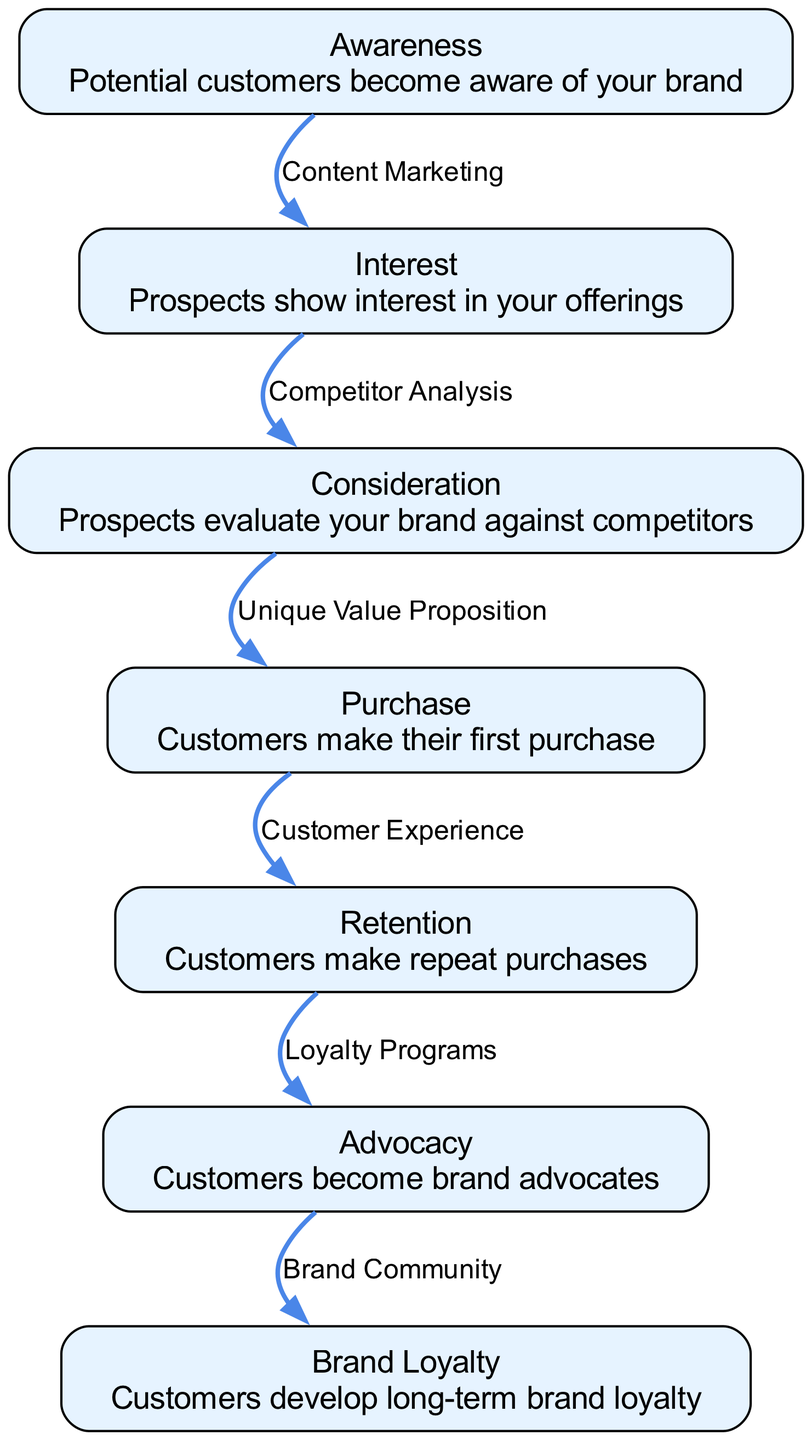What is the first stage in the marketing funnel? The first stage in the marketing funnel is "Awareness," where potential customers become aware of the brand.
Answer: Awareness How many nodes are present in the diagram? Counting the nodes listed in the diagram, there are seven distinct stages or nodes: Awareness, Interest, Consideration, Purchase, Retention, Advocacy, and Brand Loyalty.
Answer: 7 What is the relationship between Interest and Consideration? The diagram shows a directed edge from Interest to Consideration, labeled "Competitor Analysis," indicating that prospects evaluate brands against competitors after showing interest.
Answer: Competitor Analysis Which stage comes after Purchase? The stage that follows Purchase in the conversion process is Retention, where customers make repeat purchases after their initial purchase.
Answer: Retention What is the final stage of the marketing funnel? The last stage in the marketing funnel is "Brand Loyalty," where customers develop long-term loyalty to the brand after becoming advocates.
Answer: Brand Loyalty What process connects Retention to Advocacy? The process that connects Retention to Advocacy is labeled "Loyalty Programs," indicating that these initiatives incentivize customers to become advocates for the brand.
Answer: Loyalty Programs Which node represents making the first purchase? The node that represents making the first purchase in the funnel is labeled "Purchase," where customers take the initial action of buying a product or service.
Answer: Purchase What type of marketing strategy is used to move from Awareness to Interest? The marketing strategy used to transition from Awareness to Interest is "Content Marketing," indicating the role of engaging content in attracting potential customers.
Answer: Content Marketing 